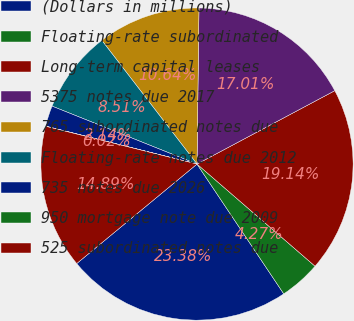<chart> <loc_0><loc_0><loc_500><loc_500><pie_chart><fcel>(Dollars in millions)<fcel>Floating-rate subordinated<fcel>Long-term capital leases<fcel>5375 notes due 2017<fcel>765 subordinated notes due<fcel>Floating-rate notes due 2012<fcel>735 notes due 2026<fcel>950 mortgage note due 2009<fcel>525 subordinated notes due<nl><fcel>23.38%<fcel>4.27%<fcel>19.14%<fcel>17.01%<fcel>10.64%<fcel>8.51%<fcel>2.14%<fcel>0.02%<fcel>14.89%<nl></chart> 